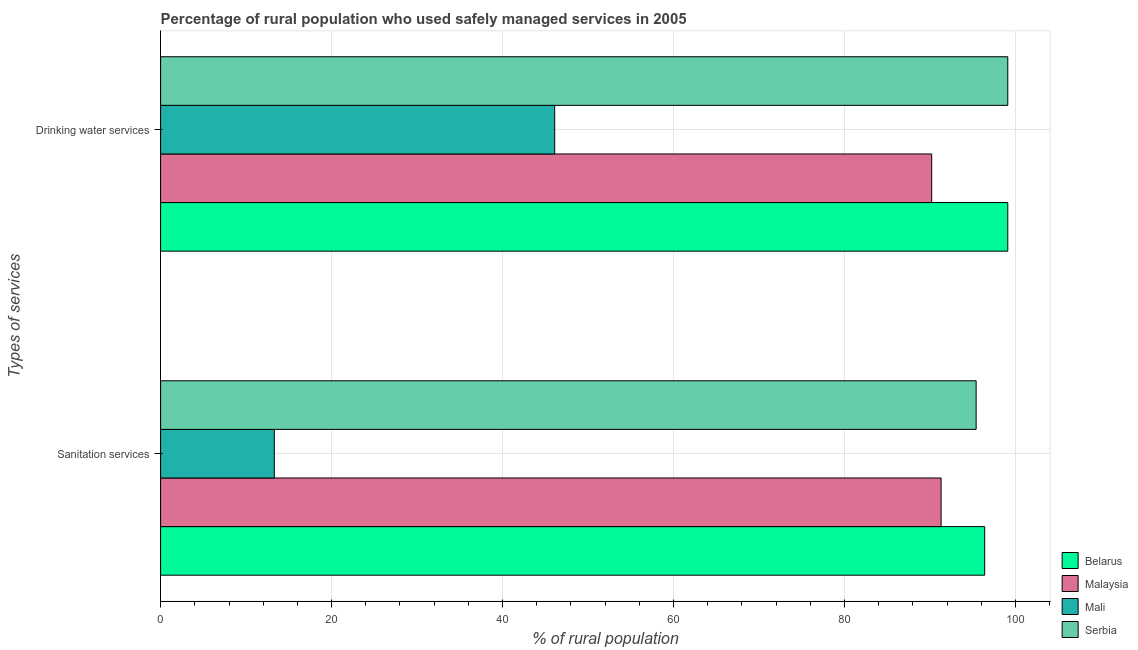How many groups of bars are there?
Provide a short and direct response. 2. Are the number of bars per tick equal to the number of legend labels?
Provide a short and direct response. Yes. How many bars are there on the 2nd tick from the top?
Make the answer very short. 4. What is the label of the 1st group of bars from the top?
Keep it short and to the point. Drinking water services. What is the percentage of rural population who used drinking water services in Serbia?
Ensure brevity in your answer.  99.1. Across all countries, what is the maximum percentage of rural population who used sanitation services?
Your answer should be very brief. 96.4. Across all countries, what is the minimum percentage of rural population who used drinking water services?
Offer a terse response. 46.1. In which country was the percentage of rural population who used drinking water services maximum?
Ensure brevity in your answer.  Belarus. In which country was the percentage of rural population who used sanitation services minimum?
Ensure brevity in your answer.  Mali. What is the total percentage of rural population who used sanitation services in the graph?
Your answer should be very brief. 296.4. What is the difference between the percentage of rural population who used drinking water services in Malaysia and that in Mali?
Ensure brevity in your answer.  44.1. What is the difference between the percentage of rural population who used drinking water services in Mali and the percentage of rural population who used sanitation services in Malaysia?
Offer a very short reply. -45.2. What is the average percentage of rural population who used sanitation services per country?
Give a very brief answer. 74.1. What is the difference between the percentage of rural population who used sanitation services and percentage of rural population who used drinking water services in Mali?
Ensure brevity in your answer.  -32.8. In how many countries, is the percentage of rural population who used sanitation services greater than 100 %?
Your answer should be very brief. 0. What is the ratio of the percentage of rural population who used sanitation services in Serbia to that in Belarus?
Keep it short and to the point. 0.99. Is the percentage of rural population who used drinking water services in Belarus less than that in Malaysia?
Provide a succinct answer. No. In how many countries, is the percentage of rural population who used sanitation services greater than the average percentage of rural population who used sanitation services taken over all countries?
Provide a succinct answer. 3. What does the 1st bar from the top in Drinking water services represents?
Your answer should be very brief. Serbia. What does the 1st bar from the bottom in Sanitation services represents?
Offer a terse response. Belarus. Are all the bars in the graph horizontal?
Give a very brief answer. Yes. How many countries are there in the graph?
Provide a succinct answer. 4. Are the values on the major ticks of X-axis written in scientific E-notation?
Your answer should be very brief. No. How many legend labels are there?
Make the answer very short. 4. How are the legend labels stacked?
Ensure brevity in your answer.  Vertical. What is the title of the graph?
Make the answer very short. Percentage of rural population who used safely managed services in 2005. What is the label or title of the X-axis?
Offer a very short reply. % of rural population. What is the label or title of the Y-axis?
Keep it short and to the point. Types of services. What is the % of rural population in Belarus in Sanitation services?
Offer a terse response. 96.4. What is the % of rural population of Malaysia in Sanitation services?
Your answer should be very brief. 91.3. What is the % of rural population in Mali in Sanitation services?
Ensure brevity in your answer.  13.3. What is the % of rural population of Serbia in Sanitation services?
Provide a succinct answer. 95.4. What is the % of rural population of Belarus in Drinking water services?
Your answer should be compact. 99.1. What is the % of rural population in Malaysia in Drinking water services?
Offer a very short reply. 90.2. What is the % of rural population of Mali in Drinking water services?
Offer a terse response. 46.1. What is the % of rural population in Serbia in Drinking water services?
Your answer should be very brief. 99.1. Across all Types of services, what is the maximum % of rural population of Belarus?
Your answer should be very brief. 99.1. Across all Types of services, what is the maximum % of rural population in Malaysia?
Provide a short and direct response. 91.3. Across all Types of services, what is the maximum % of rural population in Mali?
Give a very brief answer. 46.1. Across all Types of services, what is the maximum % of rural population in Serbia?
Give a very brief answer. 99.1. Across all Types of services, what is the minimum % of rural population in Belarus?
Your answer should be very brief. 96.4. Across all Types of services, what is the minimum % of rural population in Malaysia?
Make the answer very short. 90.2. Across all Types of services, what is the minimum % of rural population of Mali?
Make the answer very short. 13.3. Across all Types of services, what is the minimum % of rural population of Serbia?
Your answer should be compact. 95.4. What is the total % of rural population in Belarus in the graph?
Your answer should be compact. 195.5. What is the total % of rural population of Malaysia in the graph?
Offer a very short reply. 181.5. What is the total % of rural population of Mali in the graph?
Offer a terse response. 59.4. What is the total % of rural population of Serbia in the graph?
Provide a succinct answer. 194.5. What is the difference between the % of rural population in Belarus in Sanitation services and that in Drinking water services?
Ensure brevity in your answer.  -2.7. What is the difference between the % of rural population of Mali in Sanitation services and that in Drinking water services?
Your answer should be very brief. -32.8. What is the difference between the % of rural population of Belarus in Sanitation services and the % of rural population of Malaysia in Drinking water services?
Give a very brief answer. 6.2. What is the difference between the % of rural population of Belarus in Sanitation services and the % of rural population of Mali in Drinking water services?
Provide a succinct answer. 50.3. What is the difference between the % of rural population of Malaysia in Sanitation services and the % of rural population of Mali in Drinking water services?
Your answer should be compact. 45.2. What is the difference between the % of rural population in Malaysia in Sanitation services and the % of rural population in Serbia in Drinking water services?
Your answer should be very brief. -7.8. What is the difference between the % of rural population of Mali in Sanitation services and the % of rural population of Serbia in Drinking water services?
Give a very brief answer. -85.8. What is the average % of rural population in Belarus per Types of services?
Your answer should be compact. 97.75. What is the average % of rural population of Malaysia per Types of services?
Offer a terse response. 90.75. What is the average % of rural population of Mali per Types of services?
Provide a short and direct response. 29.7. What is the average % of rural population in Serbia per Types of services?
Offer a very short reply. 97.25. What is the difference between the % of rural population in Belarus and % of rural population in Mali in Sanitation services?
Make the answer very short. 83.1. What is the difference between the % of rural population in Malaysia and % of rural population in Mali in Sanitation services?
Your answer should be very brief. 78. What is the difference between the % of rural population in Malaysia and % of rural population in Serbia in Sanitation services?
Ensure brevity in your answer.  -4.1. What is the difference between the % of rural population in Mali and % of rural population in Serbia in Sanitation services?
Your response must be concise. -82.1. What is the difference between the % of rural population of Belarus and % of rural population of Malaysia in Drinking water services?
Give a very brief answer. 8.9. What is the difference between the % of rural population in Belarus and % of rural population in Mali in Drinking water services?
Give a very brief answer. 53. What is the difference between the % of rural population in Malaysia and % of rural population in Mali in Drinking water services?
Make the answer very short. 44.1. What is the difference between the % of rural population of Malaysia and % of rural population of Serbia in Drinking water services?
Offer a terse response. -8.9. What is the difference between the % of rural population of Mali and % of rural population of Serbia in Drinking water services?
Your response must be concise. -53. What is the ratio of the % of rural population of Belarus in Sanitation services to that in Drinking water services?
Make the answer very short. 0.97. What is the ratio of the % of rural population of Malaysia in Sanitation services to that in Drinking water services?
Your answer should be compact. 1.01. What is the ratio of the % of rural population of Mali in Sanitation services to that in Drinking water services?
Offer a very short reply. 0.29. What is the ratio of the % of rural population in Serbia in Sanitation services to that in Drinking water services?
Your answer should be compact. 0.96. What is the difference between the highest and the second highest % of rural population of Belarus?
Offer a very short reply. 2.7. What is the difference between the highest and the second highest % of rural population of Mali?
Give a very brief answer. 32.8. What is the difference between the highest and the second highest % of rural population in Serbia?
Your answer should be very brief. 3.7. What is the difference between the highest and the lowest % of rural population of Mali?
Provide a short and direct response. 32.8. 